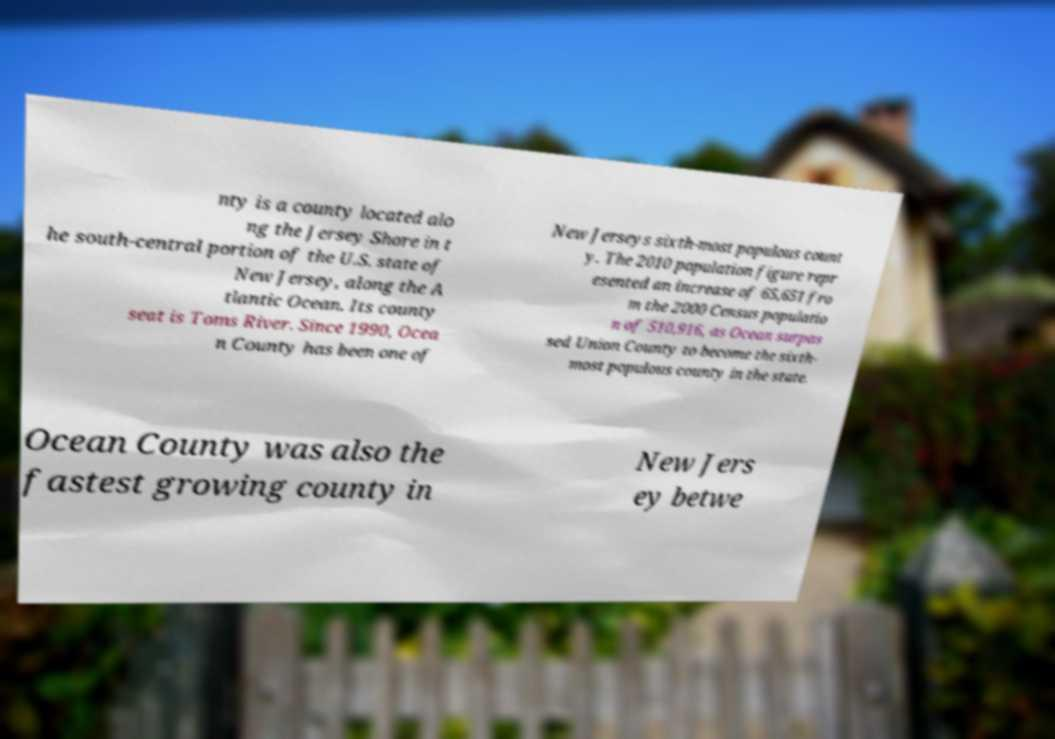There's text embedded in this image that I need extracted. Can you transcribe it verbatim? nty is a county located alo ng the Jersey Shore in t he south-central portion of the U.S. state of New Jersey, along the A tlantic Ocean. Its county seat is Toms River. Since 1990, Ocea n County has been one of New Jerseys sixth-most populous count y. The 2010 population figure repr esented an increase of 65,651 fro m the 2000 Census populatio n of 510,916, as Ocean surpas sed Union County to become the sixth- most populous county in the state. Ocean County was also the fastest growing county in New Jers ey betwe 